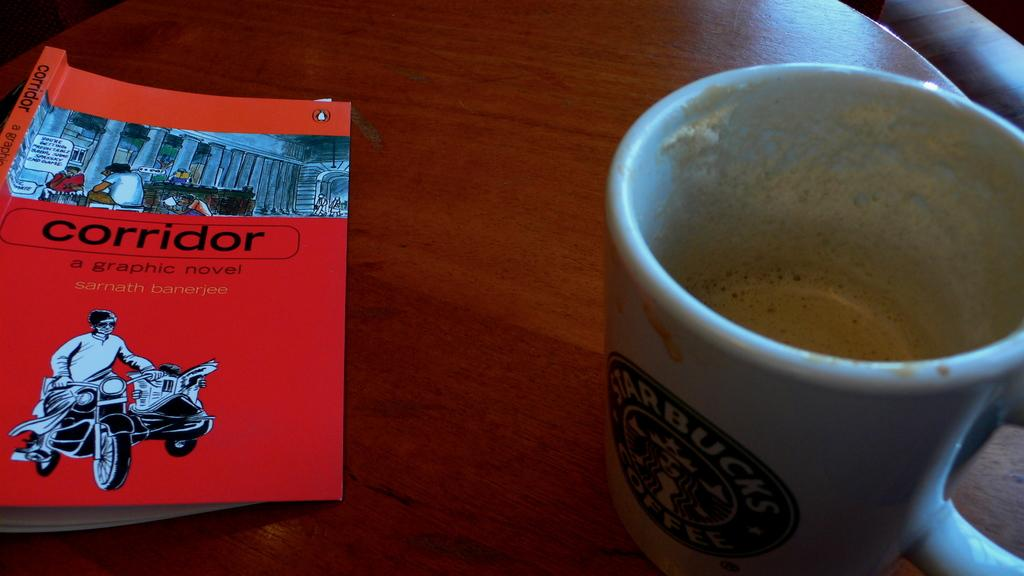<image>
Describe the image concisely. A white Starbucks coffee mug on a wooden table. 